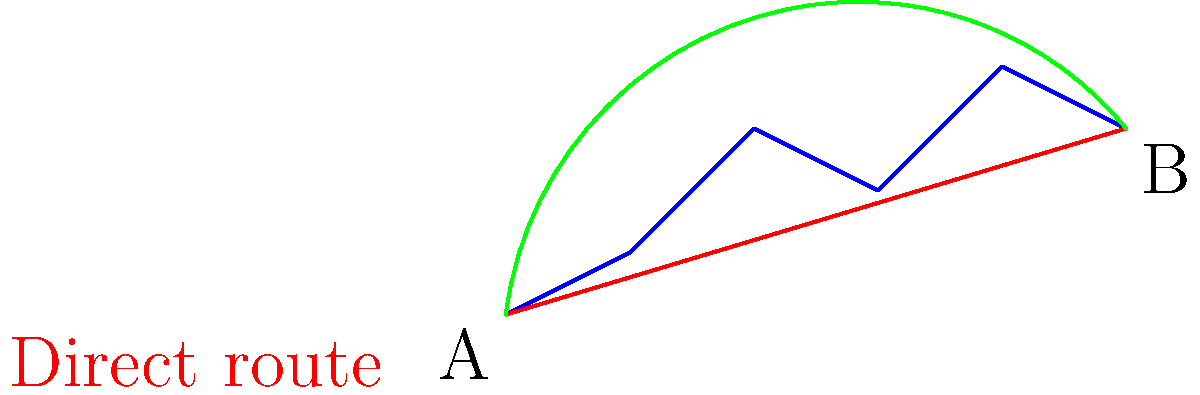An oil company needs to construct a pipeline from point A to point B across varying terrain, as shown in the diagram. The direct route (red line) is 100 km long, while the curved route (green line) following the terrain more closely is 120 km long. The cost of pipeline construction is $1 million per km on flat terrain and increases by $10,000 per km for every 1 meter increase in elevation. Given that the maximum elevation difference along the direct route is 40 m and along the curved route is 20 m, which route is more cost-effective, and what is the total cost difference between the two routes? Let's approach this step-by-step:

1) Calculate the cost for the direct route:
   - Length: 100 km
   - Max elevation difference: 40 m
   - Base cost: $1,000,000 per km
   - Additional cost: $10,000 * 40 = $400,000 per km
   - Total cost per km: $1,400,000
   - Total cost: $1,400,000 * 100 = $140,000,000

2) Calculate the cost for the curved route:
   - Length: 120 km
   - Max elevation difference: 20 m
   - Base cost: $1,000,000 per km
   - Additional cost: $10,000 * 20 = $200,000 per km
   - Total cost per km: $1,200,000
   - Total cost: $1,200,000 * 120 = $144,000,000

3) Compare the costs:
   - The direct route costs: $140,000,000
   - The curved route costs: $144,000,000
   - Difference: $144,000,000 - $140,000,000 = $4,000,000

Therefore, the direct route is more cost-effective, with a total cost difference of $4 million.
Answer: Direct route; $4 million cheaper 